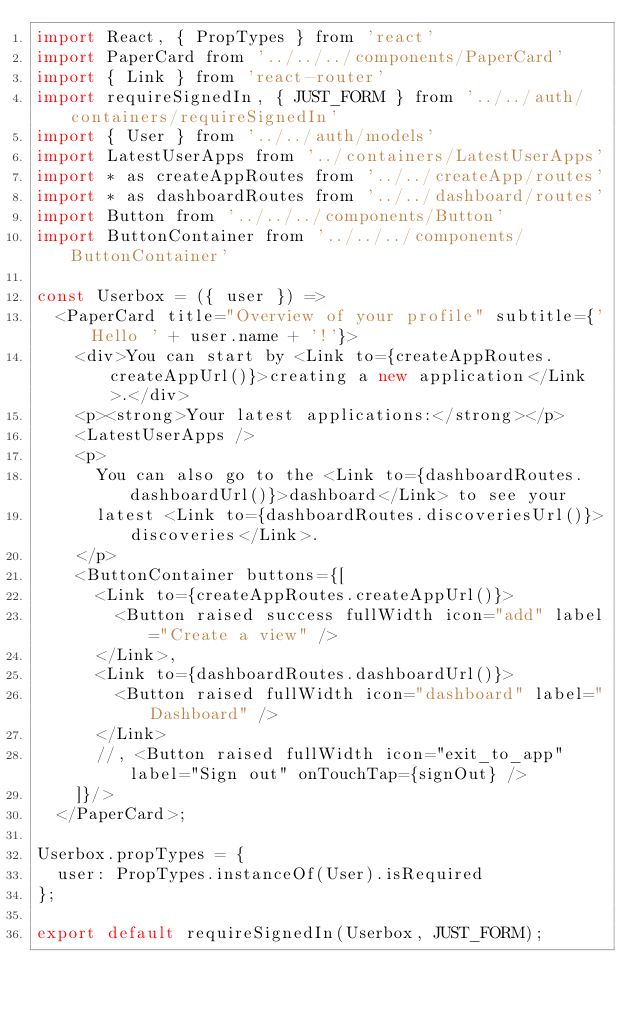Convert code to text. <code><loc_0><loc_0><loc_500><loc_500><_JavaScript_>import React, { PropTypes } from 'react'
import PaperCard from '../../../components/PaperCard'
import { Link } from 'react-router'
import requireSignedIn, { JUST_FORM } from '../../auth/containers/requireSignedIn'
import { User } from '../../auth/models'
import LatestUserApps from '../containers/LatestUserApps'
import * as createAppRoutes from '../../createApp/routes'
import * as dashboardRoutes from '../../dashboard/routes'
import Button from '../../../components/Button'
import ButtonContainer from '../../../components/ButtonContainer'

const Userbox = ({ user }) =>
  <PaperCard title="Overview of your profile" subtitle={'Hello ' + user.name + '!'}>
    <div>You can start by <Link to={createAppRoutes.createAppUrl()}>creating a new application</Link>.</div>
    <p><strong>Your latest applications:</strong></p>
    <LatestUserApps />
    <p>
      You can also go to the <Link to={dashboardRoutes.dashboardUrl()}>dashboard</Link> to see your
      latest <Link to={dashboardRoutes.discoveriesUrl()}>discoveries</Link>.
    </p>
    <ButtonContainer buttons={[
      <Link to={createAppRoutes.createAppUrl()}>
        <Button raised success fullWidth icon="add" label="Create a view" />
      </Link>,
      <Link to={dashboardRoutes.dashboardUrl()}>
        <Button raised fullWidth icon="dashboard" label="Dashboard" />
      </Link>
      //, <Button raised fullWidth icon="exit_to_app" label="Sign out" onTouchTap={signOut} />
    ]}/>
  </PaperCard>;

Userbox.propTypes = {
  user: PropTypes.instanceOf(User).isRequired
};

export default requireSignedIn(Userbox, JUST_FORM);
</code> 